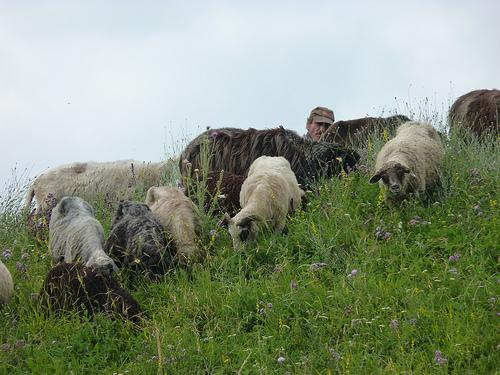In the context of the product advertisement task, describe the benefits of sheep's wool. Sheep's wool is a natural, renewable, and warm material, perfect for making cozy and comfortable clothing, blankets, and more. For the visual entailment task, tell me what the man is doing and what he is wearing. The man is standing behind the animals in the pasture, looking at the camera, and wearing a brown baseball hat. In a multi-choice VQA task manner, identify the number of sheep present in the image. The image shows a large herd of 9 sheep grazing on top of a grassy hill. For the visual entailment task, mention the attribute of the animal with a unique eye feature. The animal has a black ring around one of its eyes. Describe the interaction between the main human subject and the animals based on the referential expression grounding task. The man, who is wearing a hat, is seen standing behind and with the animals in the pasture while looking directly at the camera. Explain the environment where the animals are and the type of weather in the image. The animals are grazing in a pasture filled with long green grass, and the sky is cloudy and grey. Regarding the product advertisement task, discuss the landscape and elements that make the pasture picturesque. The pasture is a beautiful scene with green grass, vibrant purple and yellow flowers, and surrounding grey skies, making it an ideal location for a peaceful and natural experience. Identify the primary animal depicted in the image along with its action. The main animal is a black sheep, which is feeding on the grass in the pasture. For the multi-choice VQA task, provide the color of the flowers surrounded by tall green grass in the field. There are purple and yellow flowers in the field with tall green grass. 